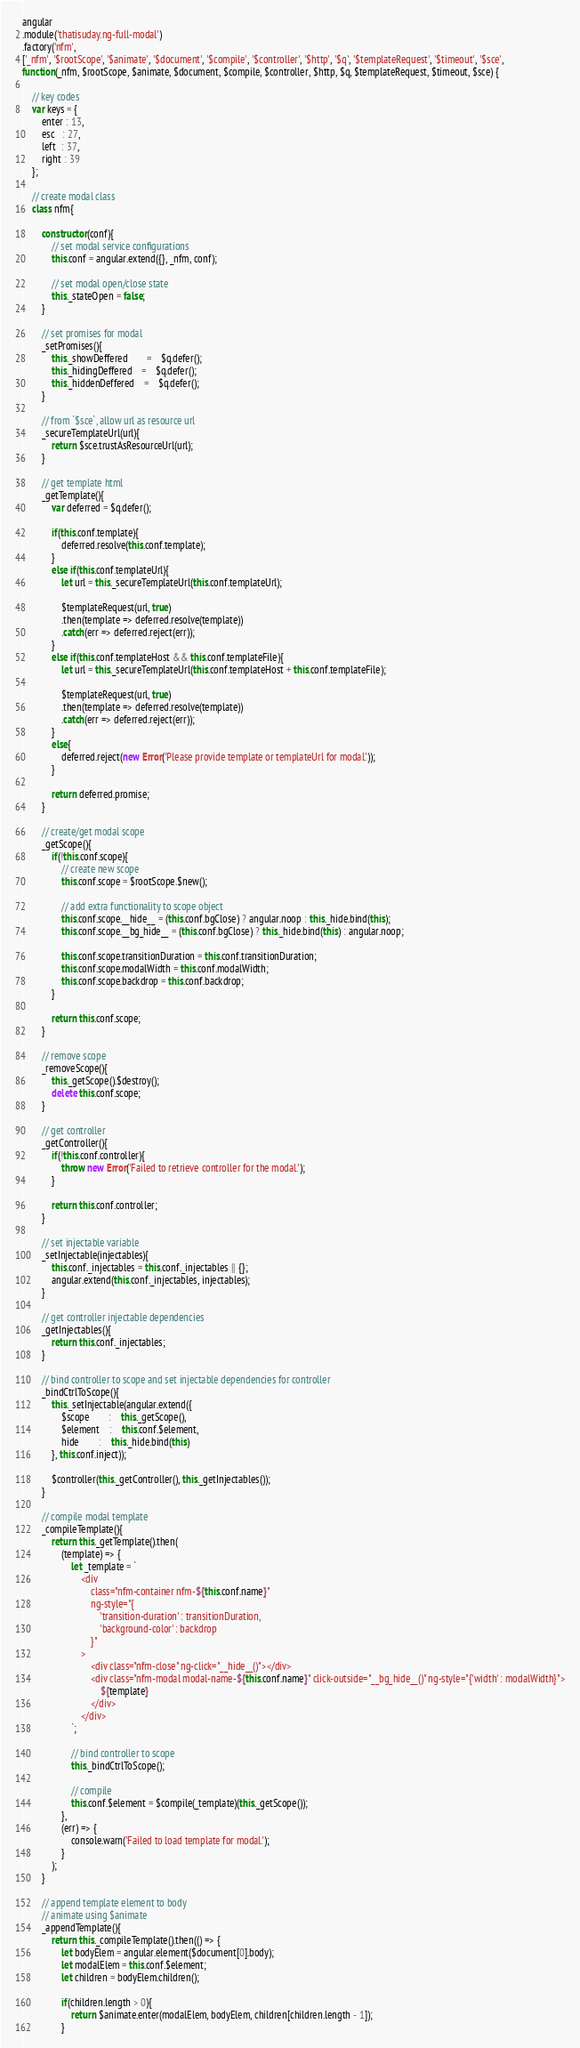<code> <loc_0><loc_0><loc_500><loc_500><_JavaScript_>angular
.module('thatisuday.ng-full-modal')
.factory('nfm',
['_nfm', '$rootScope', '$animate', '$document', '$compile', '$controller', '$http', '$q', '$templateRequest', '$timeout', '$sce',
function(_nfm, $rootScope, $animate, $document, $compile, $controller, $http, $q, $templateRequest, $timeout, $sce) {
	
	// key codes
	var keys = {
		enter : 13,
		esc   : 27,
		left  : 37,
		right : 39
	};
	
	// create modal class
	class nfm{

		constructor(conf){
			// set modal service configurations
			this.conf = angular.extend({}, _nfm, conf);

			// set modal open/close state
			this._stateOpen = false;
		}

		// set promises for modal
		_setPromises(){
			this._showDeffered 		= 	$q.defer();
			this._hidingDeffered 	= 	$q.defer();
			this._hiddenDeffered 	= 	$q.defer();
		}

		// from `$sce`, allow url as resource url
		_secureTemplateUrl(url){
			return $sce.trustAsResourceUrl(url);
		}

		// get template html
		_getTemplate(){
			var deferred = $q.defer();
			
			if(this.conf.template){
				deferred.resolve(this.conf.template);
			}
			else if(this.conf.templateUrl){
				let url = this._secureTemplateUrl(this.conf.templateUrl);

				$templateRequest(url, true)
				.then(template => deferred.resolve(template))
				.catch(err => deferred.reject(err));
			}
			else if(this.conf.templateHost && this.conf.templateFile){
				let url = this._secureTemplateUrl(this.conf.templateHost + this.conf.templateFile);

				$templateRequest(url, true)
				.then(template => deferred.resolve(template))
				.catch(err => deferred.reject(err));
			}
			else{
				deferred.reject(new Error('Please provide template or templateUrl for modal.'));
			}

			return deferred.promise;
		}

		// create/get modal scope
		_getScope(){
			if(!this.conf.scope){
				// create new scope
				this.conf.scope = $rootScope.$new();
			
				// add extra functionality to scope object
				this.conf.scope.__hide__ = (this.conf.bgClose) ? angular.noop : this._hide.bind(this);
				this.conf.scope.__bg_hide__ = (this.conf.bgClose) ? this._hide.bind(this) : angular.noop;

				this.conf.scope.transitionDuration = this.conf.transitionDuration;
				this.conf.scope.modalWidth = this.conf.modalWidth;
				this.conf.scope.backdrop = this.conf.backdrop;
			}

			return this.conf.scope;
		}

		// remove scope
		_removeScope(){
			this._getScope().$destroy();
			delete this.conf.scope;
		}

		// get controller
		_getController(){
			if(!this.conf.controller){
				throw new Error('Failed to retrieve controller for the modal.');
			}

			return this.conf.controller;
		}

		// set injectable variable
		_setInjectable(injectables){
			this.conf._injectables = this.conf._injectables || {};
			angular.extend(this.conf._injectables, injectables);
		}

		// get controller injectable dependencies
		_getInjectables(){
			return this.conf._injectables;
		}

		// bind controller to scope and set injectable dependencies for controller
		_bindCtrlToScope(){
			this._setInjectable(angular.extend({
				$scope 		: 	this._getScope(),
				$element 	: 	this.conf.$element,
				hide 		: 	this._hide.bind(this)
			}, this.conf.inject));

			$controller(this._getController(), this._getInjectables());
		}

		// compile modal template
		_compileTemplate(){
			return this._getTemplate().then(
				(template) => {
					let _template = `
						<div
							class="nfm-container nfm-${this.conf.name}"
							ng-style="{
								'transition-duration' : transitionDuration,
								'background-color' : backdrop
							}"
						>
							<div class="nfm-close" ng-click="__hide__()"></div>
							<div class="nfm-modal modal-name-${this.conf.name}" click-outside="__bg_hide__()" ng-style="{'width' : modalWidth}">
								${template}
							</div>
						</div>
					`;

					// bind controller to scope
					this._bindCtrlToScope();

					// compile
					this.conf.$element = $compile(_template)(this._getScope());
				},
				(err) => {
					console.warn('Failed to load template for modal.');
				}
			);
		}

		// append template element to body
		// animate using $animate
		_appendTemplate(){
			return this._compileTemplate().then(() => {
				let bodyElem = angular.element($document[0].body);
				let modalElem = this.conf.$element;
				let children = bodyElem.children();

				if(children.length > 0){
					return $animate.enter(modalElem, bodyElem, children[children.length - 1]);
				}
</code> 